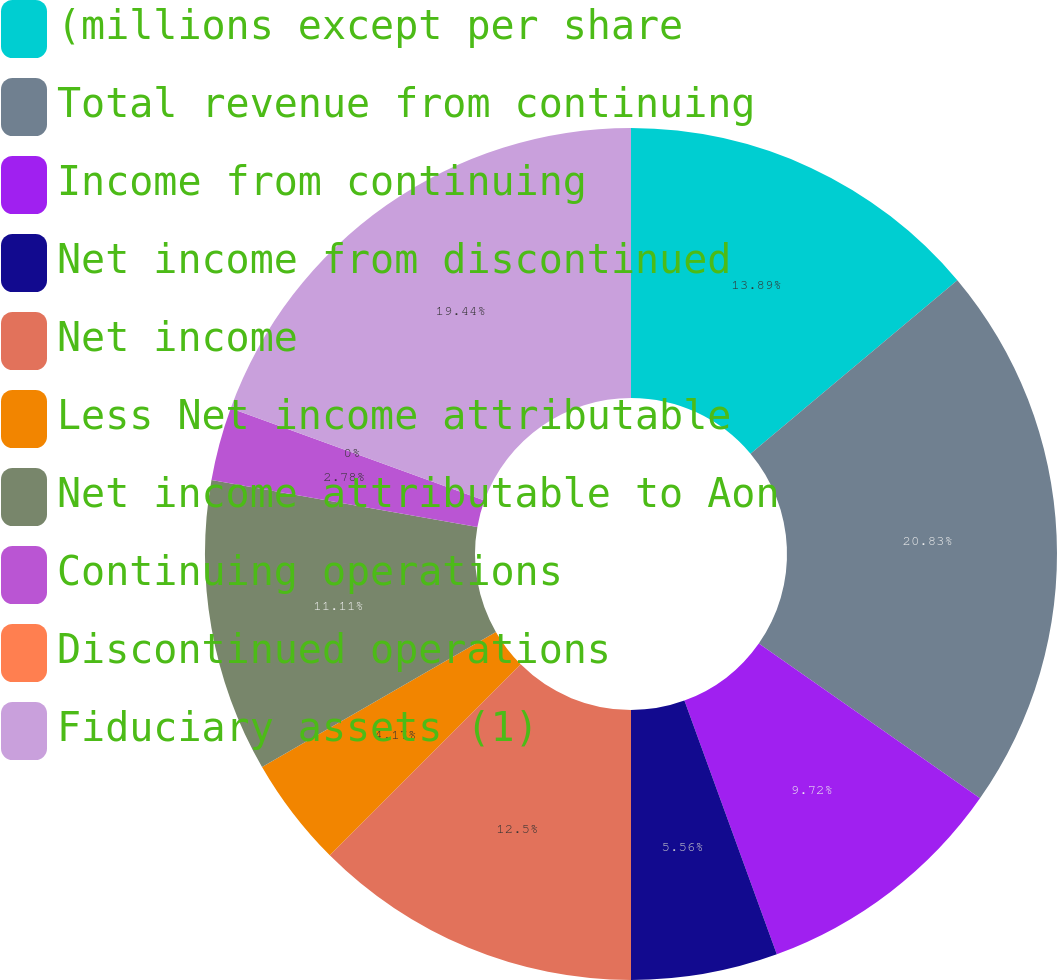Convert chart to OTSL. <chart><loc_0><loc_0><loc_500><loc_500><pie_chart><fcel>(millions except per share<fcel>Total revenue from continuing<fcel>Income from continuing<fcel>Net income from discontinued<fcel>Net income<fcel>Less Net income attributable<fcel>Net income attributable to Aon<fcel>Continuing operations<fcel>Discontinued operations<fcel>Fiduciary assets (1)<nl><fcel>13.89%<fcel>20.83%<fcel>9.72%<fcel>5.56%<fcel>12.5%<fcel>4.17%<fcel>11.11%<fcel>2.78%<fcel>0.0%<fcel>19.44%<nl></chart> 